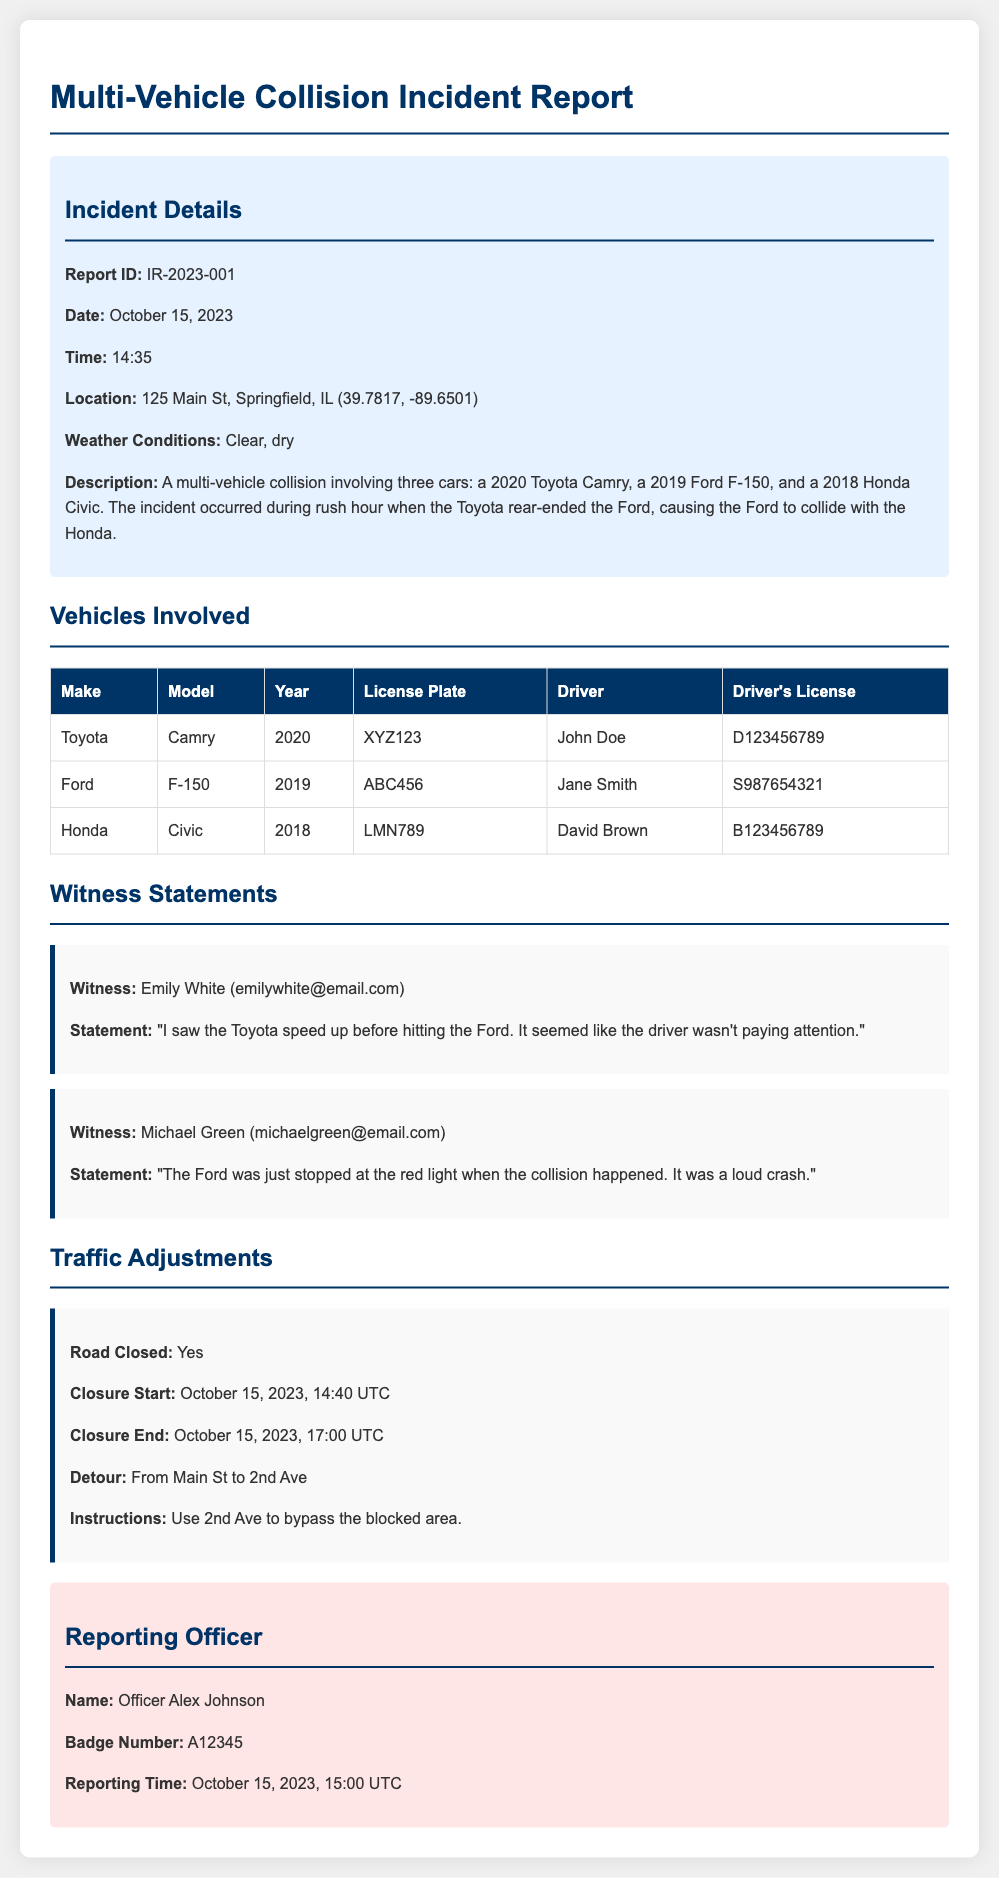What is the report ID? The report ID is specified in the incident details section of the document.
Answer: IR-2023-001 What is the date of the incident? The date is mentioned in the incident details section of the document.
Answer: October 15, 2023 Who was driving the Honda? The driver's name is provided in the vehicles involved section of the document.
Answer: David Brown What did witness Emily White observe? The witness statement summarizes observations made during the incident.
Answer: The Toyota speed up before hitting the Ford At what time did the road closure start? The road closure start time is listed in the traffic adjustments section of the document.
Answer: October 15, 2023, 14:40 UTC What was the detour route? The detour information is included in the traffic adjustments section.
Answer: From Main St to 2nd Ave How many vehicles were involved in the collision? The number of vehicles is mentioned in the incident description.
Answer: Three What was the weather condition during the incident? The weather condition is noted in the incident details section.
Answer: Clear, dry 